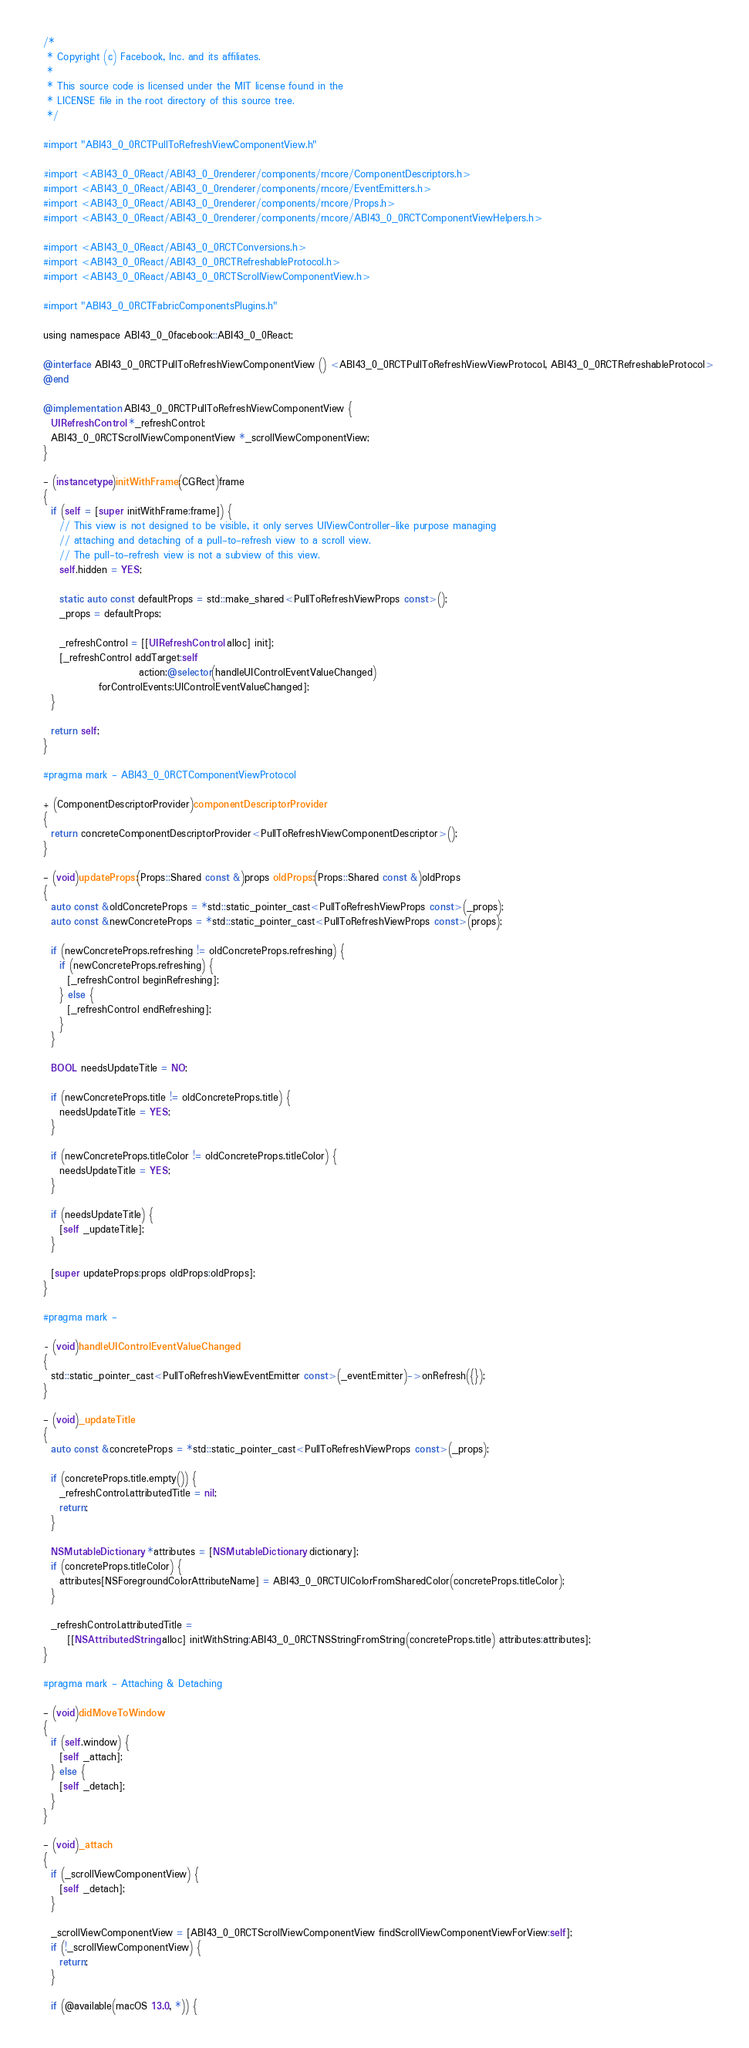<code> <loc_0><loc_0><loc_500><loc_500><_ObjectiveC_>/*
 * Copyright (c) Facebook, Inc. and its affiliates.
 *
 * This source code is licensed under the MIT license found in the
 * LICENSE file in the root directory of this source tree.
 */

#import "ABI43_0_0RCTPullToRefreshViewComponentView.h"

#import <ABI43_0_0React/ABI43_0_0renderer/components/rncore/ComponentDescriptors.h>
#import <ABI43_0_0React/ABI43_0_0renderer/components/rncore/EventEmitters.h>
#import <ABI43_0_0React/ABI43_0_0renderer/components/rncore/Props.h>
#import <ABI43_0_0React/ABI43_0_0renderer/components/rncore/ABI43_0_0RCTComponentViewHelpers.h>

#import <ABI43_0_0React/ABI43_0_0RCTConversions.h>
#import <ABI43_0_0React/ABI43_0_0RCTRefreshableProtocol.h>
#import <ABI43_0_0React/ABI43_0_0RCTScrollViewComponentView.h>

#import "ABI43_0_0RCTFabricComponentsPlugins.h"

using namespace ABI43_0_0facebook::ABI43_0_0React;

@interface ABI43_0_0RCTPullToRefreshViewComponentView () <ABI43_0_0RCTPullToRefreshViewViewProtocol, ABI43_0_0RCTRefreshableProtocol>
@end

@implementation ABI43_0_0RCTPullToRefreshViewComponentView {
  UIRefreshControl *_refreshControl;
  ABI43_0_0RCTScrollViewComponentView *_scrollViewComponentView;
}

- (instancetype)initWithFrame:(CGRect)frame
{
  if (self = [super initWithFrame:frame]) {
    // This view is not designed to be visible, it only serves UIViewController-like purpose managing
    // attaching and detaching of a pull-to-refresh view to a scroll view.
    // The pull-to-refresh view is not a subview of this view.
    self.hidden = YES;

    static auto const defaultProps = std::make_shared<PullToRefreshViewProps const>();
    _props = defaultProps;

    _refreshControl = [[UIRefreshControl alloc] init];
    [_refreshControl addTarget:self
                        action:@selector(handleUIControlEventValueChanged)
              forControlEvents:UIControlEventValueChanged];
  }

  return self;
}

#pragma mark - ABI43_0_0RCTComponentViewProtocol

+ (ComponentDescriptorProvider)componentDescriptorProvider
{
  return concreteComponentDescriptorProvider<PullToRefreshViewComponentDescriptor>();
}

- (void)updateProps:(Props::Shared const &)props oldProps:(Props::Shared const &)oldProps
{
  auto const &oldConcreteProps = *std::static_pointer_cast<PullToRefreshViewProps const>(_props);
  auto const &newConcreteProps = *std::static_pointer_cast<PullToRefreshViewProps const>(props);

  if (newConcreteProps.refreshing != oldConcreteProps.refreshing) {
    if (newConcreteProps.refreshing) {
      [_refreshControl beginRefreshing];
    } else {
      [_refreshControl endRefreshing];
    }
  }

  BOOL needsUpdateTitle = NO;

  if (newConcreteProps.title != oldConcreteProps.title) {
    needsUpdateTitle = YES;
  }

  if (newConcreteProps.titleColor != oldConcreteProps.titleColor) {
    needsUpdateTitle = YES;
  }

  if (needsUpdateTitle) {
    [self _updateTitle];
  }

  [super updateProps:props oldProps:oldProps];
}

#pragma mark -

- (void)handleUIControlEventValueChanged
{
  std::static_pointer_cast<PullToRefreshViewEventEmitter const>(_eventEmitter)->onRefresh({});
}

- (void)_updateTitle
{
  auto const &concreteProps = *std::static_pointer_cast<PullToRefreshViewProps const>(_props);

  if (concreteProps.title.empty()) {
    _refreshControl.attributedTitle = nil;
    return;
  }

  NSMutableDictionary *attributes = [NSMutableDictionary dictionary];
  if (concreteProps.titleColor) {
    attributes[NSForegroundColorAttributeName] = ABI43_0_0RCTUIColorFromSharedColor(concreteProps.titleColor);
  }

  _refreshControl.attributedTitle =
      [[NSAttributedString alloc] initWithString:ABI43_0_0RCTNSStringFromString(concreteProps.title) attributes:attributes];
}

#pragma mark - Attaching & Detaching

- (void)didMoveToWindow
{
  if (self.window) {
    [self _attach];
  } else {
    [self _detach];
  }
}

- (void)_attach
{
  if (_scrollViewComponentView) {
    [self _detach];
  }

  _scrollViewComponentView = [ABI43_0_0RCTScrollViewComponentView findScrollViewComponentViewForView:self];
  if (!_scrollViewComponentView) {
    return;
  }

  if (@available(macOS 13.0, *)) {</code> 